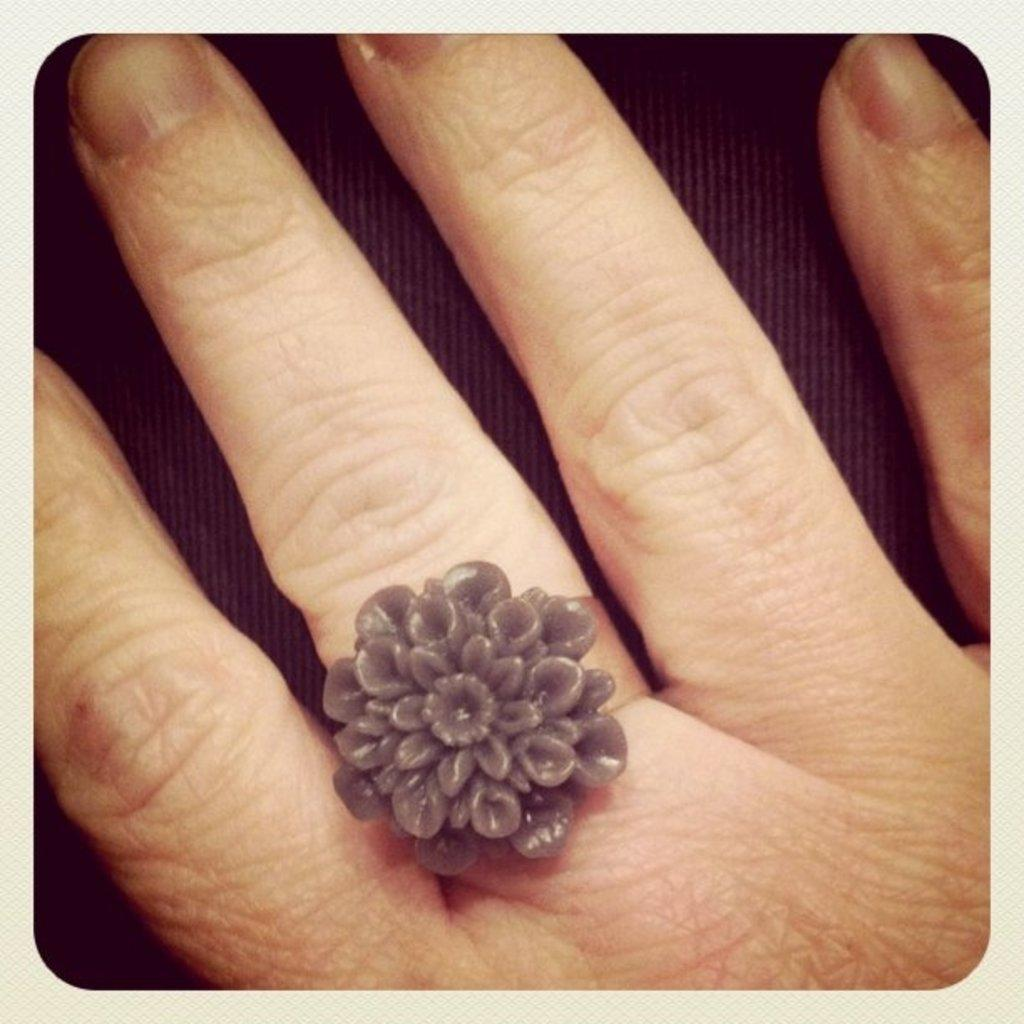What type of jewelry is visible on the person's finger in the image? There is a ring on a person's middle finger in the image. What type of argument is taking place in the image? There is no argument present in the image; it only shows a ring on a person's middle finger. Can you tell me where the church is located in the image? There is no church present in the image. 